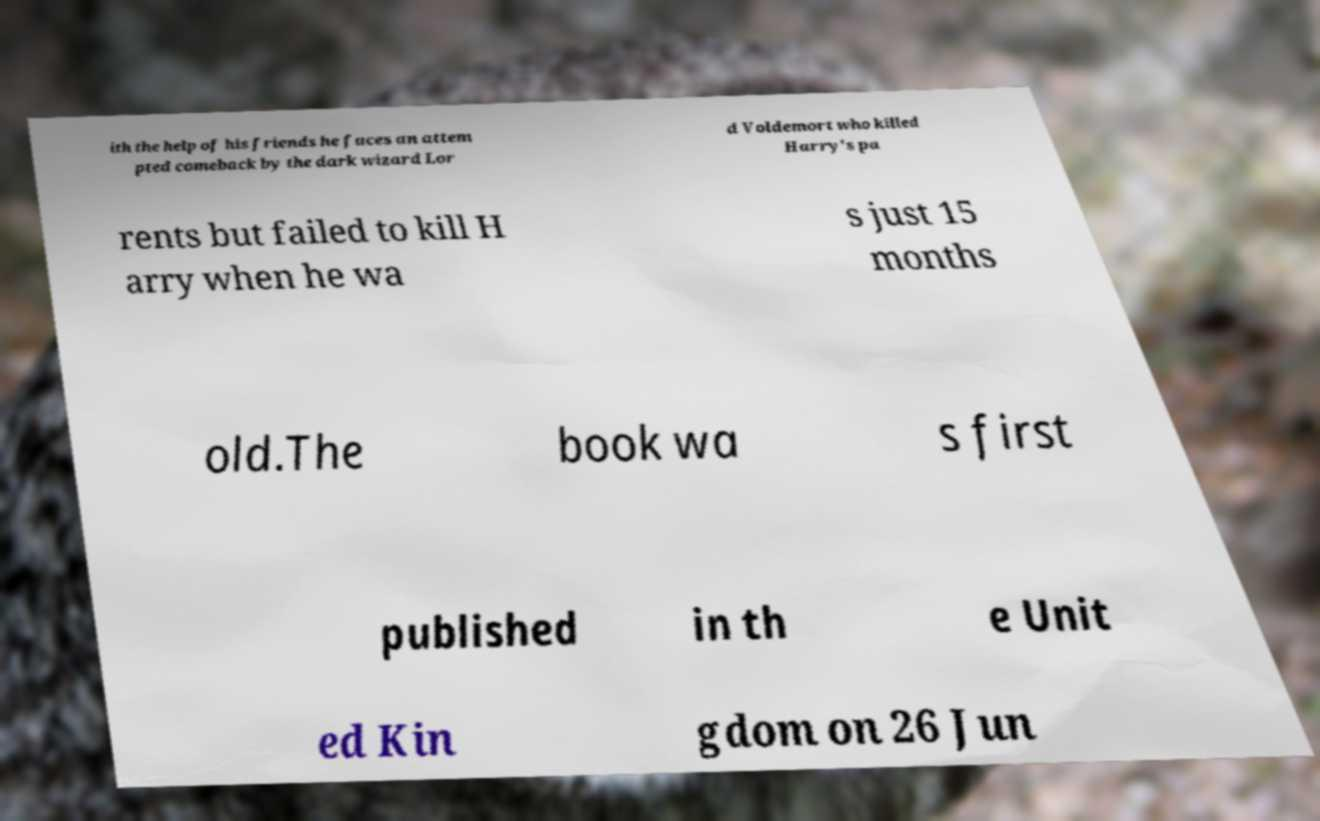Please read and relay the text visible in this image. What does it say? ith the help of his friends he faces an attem pted comeback by the dark wizard Lor d Voldemort who killed Harry's pa rents but failed to kill H arry when he wa s just 15 months old.The book wa s first published in th e Unit ed Kin gdom on 26 Jun 